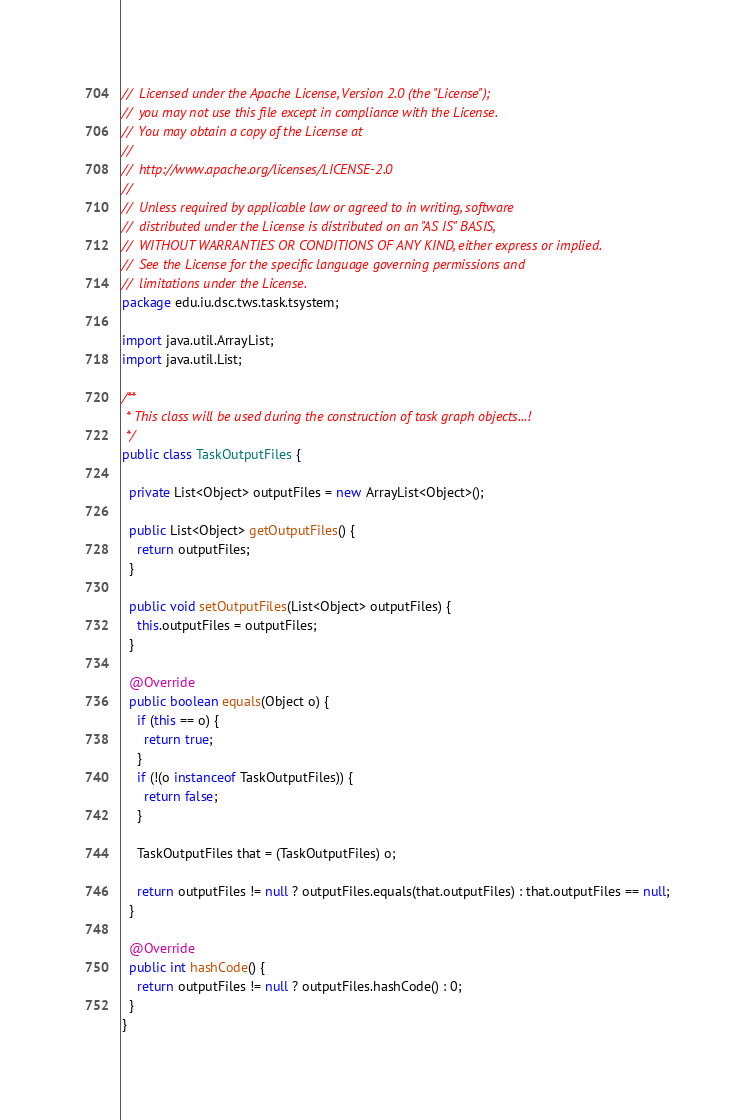<code> <loc_0><loc_0><loc_500><loc_500><_Java_>//  Licensed under the Apache License, Version 2.0 (the "License");
//  you may not use this file except in compliance with the License.
//  You may obtain a copy of the License at
//
//  http://www.apache.org/licenses/LICENSE-2.0
//
//  Unless required by applicable law or agreed to in writing, software
//  distributed under the License is distributed on an "AS IS" BASIS,
//  WITHOUT WARRANTIES OR CONDITIONS OF ANY KIND, either express or implied.
//  See the License for the specific language governing permissions and
//  limitations under the License.
package edu.iu.dsc.tws.task.tsystem;

import java.util.ArrayList;
import java.util.List;

/**
 * This class will be used during the construction of task graph objects...!
 */
public class TaskOutputFiles {

  private List<Object> outputFiles = new ArrayList<Object>();

  public List<Object> getOutputFiles() {
    return outputFiles;
  }

  public void setOutputFiles(List<Object> outputFiles) {
    this.outputFiles = outputFiles;
  }

  @Override
  public boolean equals(Object o) {
    if (this == o) {
      return true;
    }
    if (!(o instanceof TaskOutputFiles)) {
      return false;
    }

    TaskOutputFiles that = (TaskOutputFiles) o;

    return outputFiles != null ? outputFiles.equals(that.outputFiles) : that.outputFiles == null;
  }

  @Override
  public int hashCode() {
    return outputFiles != null ? outputFiles.hashCode() : 0;
  }
}

</code> 